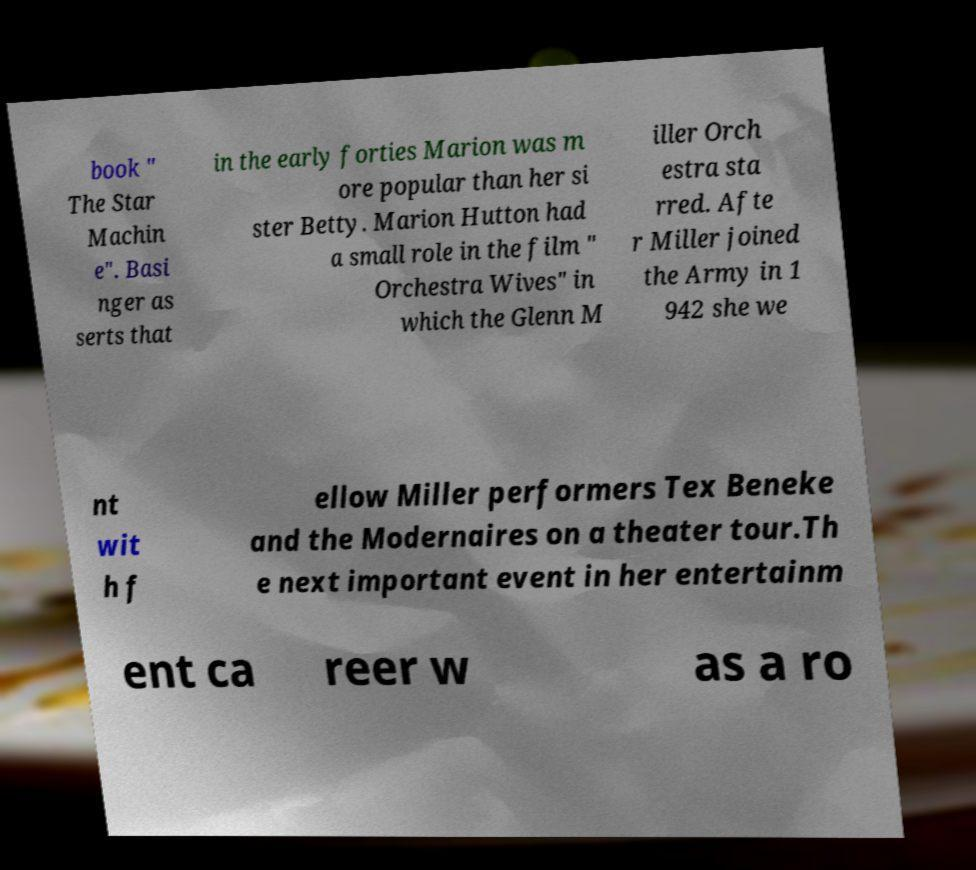For documentation purposes, I need the text within this image transcribed. Could you provide that? book " The Star Machin e". Basi nger as serts that in the early forties Marion was m ore popular than her si ster Betty. Marion Hutton had a small role in the film " Orchestra Wives" in which the Glenn M iller Orch estra sta rred. Afte r Miller joined the Army in 1 942 she we nt wit h f ellow Miller performers Tex Beneke and the Modernaires on a theater tour.Th e next important event in her entertainm ent ca reer w as a ro 